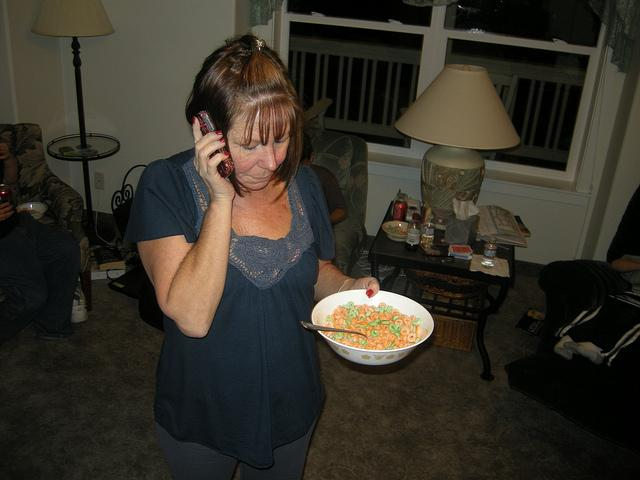What age group normally eats this food? Please explain your reasoning. kids. The cereal is colored. children like colors. 